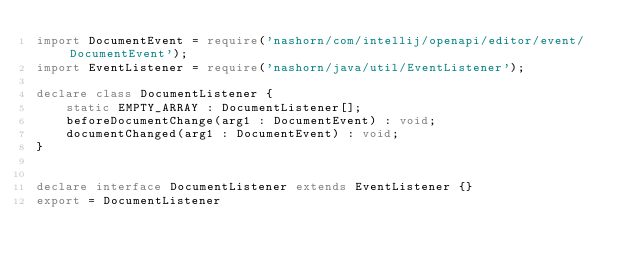Convert code to text. <code><loc_0><loc_0><loc_500><loc_500><_TypeScript_>import DocumentEvent = require('nashorn/com/intellij/openapi/editor/event/DocumentEvent');
import EventListener = require('nashorn/java/util/EventListener');

declare class DocumentListener {
	static EMPTY_ARRAY : DocumentListener[];
	beforeDocumentChange(arg1 : DocumentEvent) : void;
	documentChanged(arg1 : DocumentEvent) : void;
}


declare interface DocumentListener extends EventListener {}
export = DocumentListener
</code> 